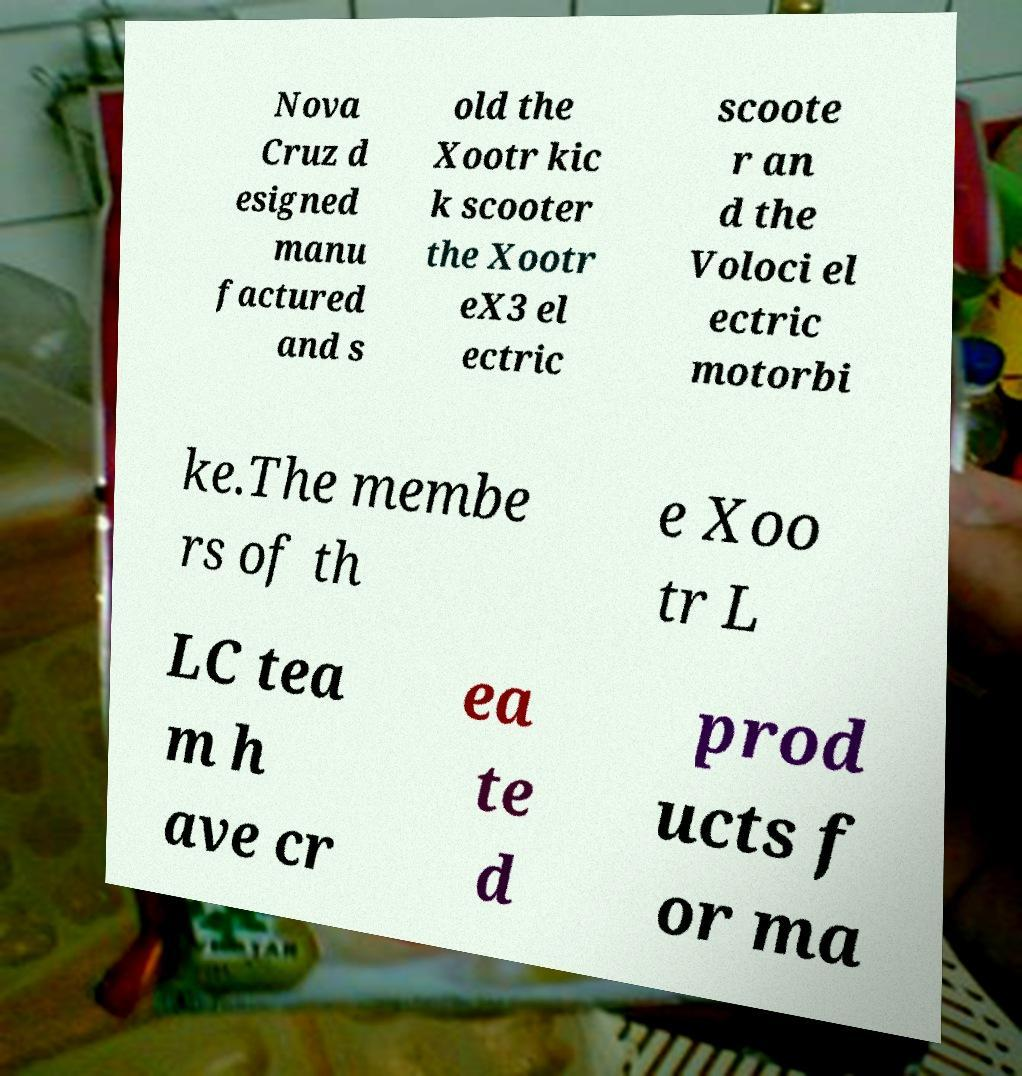For documentation purposes, I need the text within this image transcribed. Could you provide that? Nova Cruz d esigned manu factured and s old the Xootr kic k scooter the Xootr eX3 el ectric scoote r an d the Voloci el ectric motorbi ke.The membe rs of th e Xoo tr L LC tea m h ave cr ea te d prod ucts f or ma 